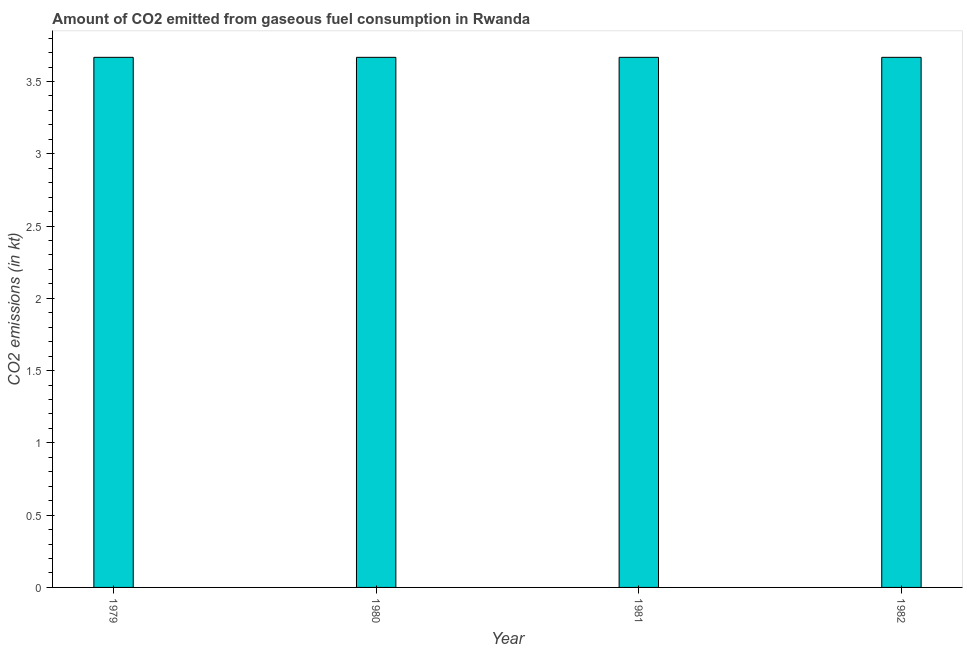Does the graph contain grids?
Give a very brief answer. No. What is the title of the graph?
Provide a succinct answer. Amount of CO2 emitted from gaseous fuel consumption in Rwanda. What is the label or title of the X-axis?
Provide a short and direct response. Year. What is the label or title of the Y-axis?
Provide a succinct answer. CO2 emissions (in kt). What is the co2 emissions from gaseous fuel consumption in 1979?
Give a very brief answer. 3.67. Across all years, what is the maximum co2 emissions from gaseous fuel consumption?
Keep it short and to the point. 3.67. Across all years, what is the minimum co2 emissions from gaseous fuel consumption?
Your answer should be compact. 3.67. In which year was the co2 emissions from gaseous fuel consumption maximum?
Keep it short and to the point. 1979. In which year was the co2 emissions from gaseous fuel consumption minimum?
Ensure brevity in your answer.  1979. What is the sum of the co2 emissions from gaseous fuel consumption?
Make the answer very short. 14.67. What is the average co2 emissions from gaseous fuel consumption per year?
Provide a succinct answer. 3.67. What is the median co2 emissions from gaseous fuel consumption?
Offer a very short reply. 3.67. What is the ratio of the co2 emissions from gaseous fuel consumption in 1981 to that in 1982?
Offer a terse response. 1. Is the sum of the co2 emissions from gaseous fuel consumption in 1980 and 1982 greater than the maximum co2 emissions from gaseous fuel consumption across all years?
Provide a short and direct response. Yes. What is the difference between the highest and the lowest co2 emissions from gaseous fuel consumption?
Your answer should be compact. 0. In how many years, is the co2 emissions from gaseous fuel consumption greater than the average co2 emissions from gaseous fuel consumption taken over all years?
Provide a succinct answer. 0. How many years are there in the graph?
Your answer should be very brief. 4. What is the CO2 emissions (in kt) of 1979?
Give a very brief answer. 3.67. What is the CO2 emissions (in kt) of 1980?
Offer a very short reply. 3.67. What is the CO2 emissions (in kt) of 1981?
Provide a succinct answer. 3.67. What is the CO2 emissions (in kt) of 1982?
Provide a short and direct response. 3.67. What is the difference between the CO2 emissions (in kt) in 1979 and 1980?
Provide a short and direct response. 0. What is the difference between the CO2 emissions (in kt) in 1979 and 1981?
Your answer should be very brief. 0. What is the difference between the CO2 emissions (in kt) in 1980 and 1981?
Your answer should be very brief. 0. What is the ratio of the CO2 emissions (in kt) in 1979 to that in 1980?
Offer a terse response. 1. What is the ratio of the CO2 emissions (in kt) in 1979 to that in 1982?
Keep it short and to the point. 1. 